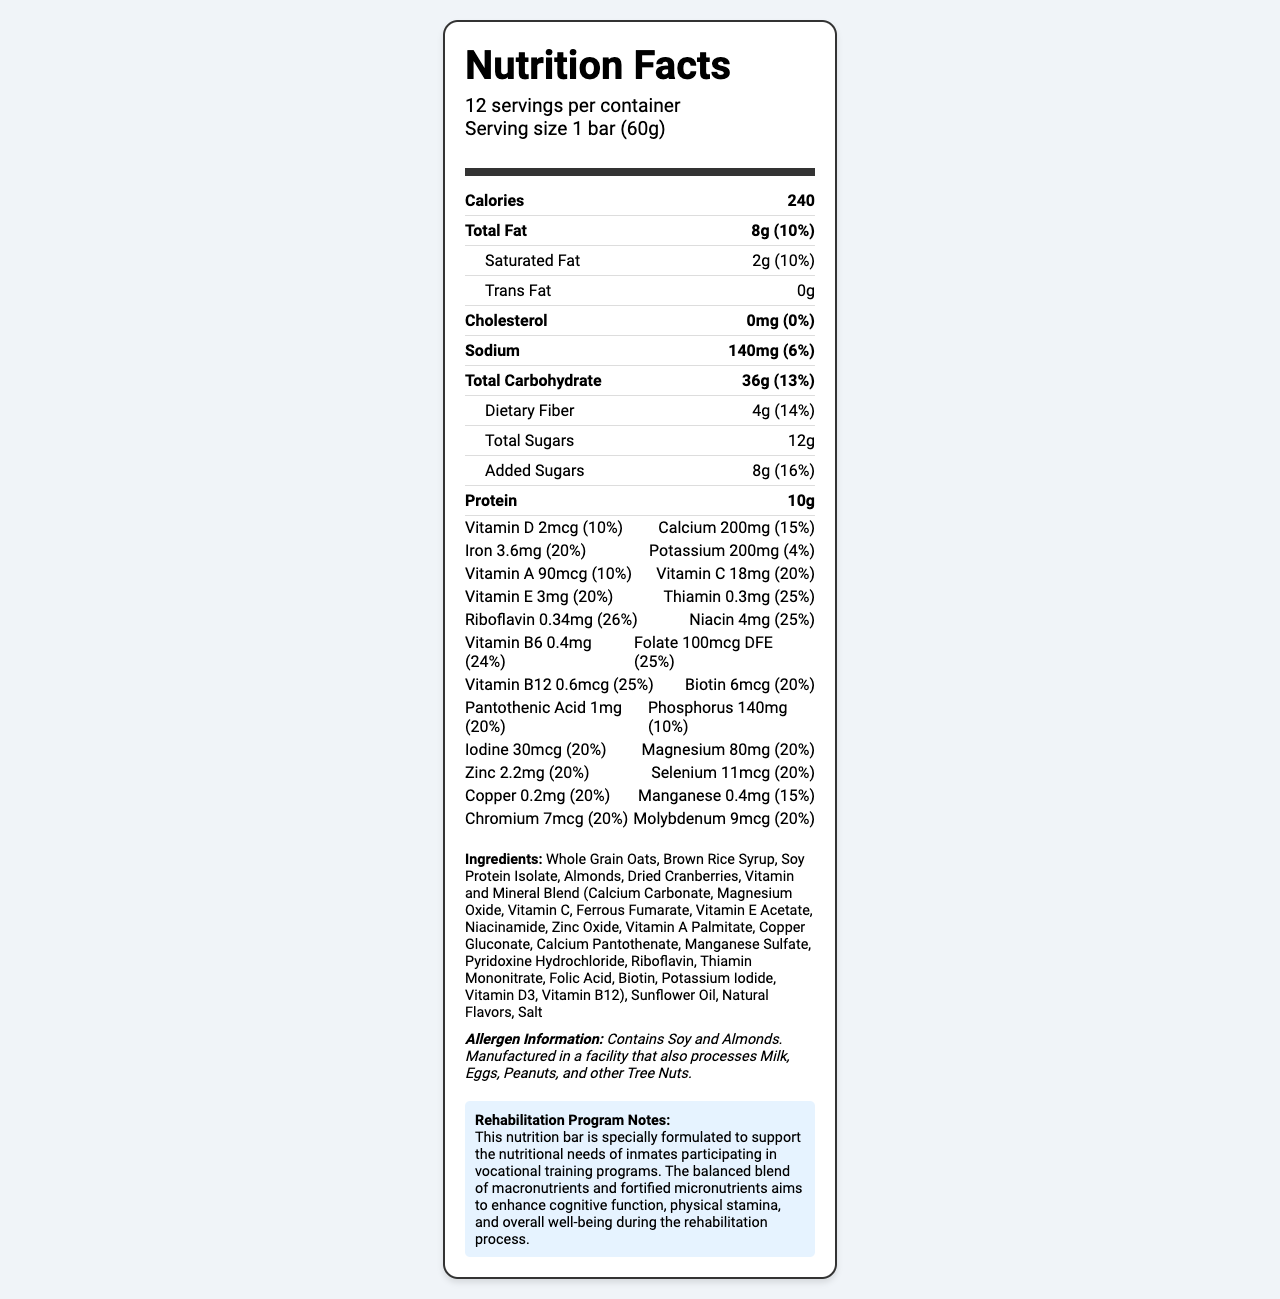what is the serving size? The serving size is clearly stated at the beginning of the document.
Answer: 1 bar (60g) how many servings are there per container? The document states that there are 12 servings per container.
Answer: 12 what is the total fat content per serving? The total fat content per serving is listed as 8g.
Answer: 8g how much protein does each serving contain? Each serving contains 10g of protein, as indicated in the nutrient row for protein.
Answer: 10g how much vitamin C is in each serving? The amount of vitamin C per serving is listed as 18mg in the vitamin-mineral row.
Answer: 18mg what percentage of the daily value is iron per serving? The daily value percentage for iron per serving is 20%, as shown in the document.
Answer: 20% which of the following vitamins has the highest daily value percentage? A. Vitamin D B. Vitamin C C. Thiamin D. Niacin Niacin has a daily value percentage of 25%, which is the highest among the listed options.
Answer: D. Niacin which ingredient is not included in the CorrectNutrition Vocational Boost Bar? A. Whole Grain Oats B. Soy Protein Isolate C. Chocolate D. Almonds Chocolate is not listed in the ingredient list, while the other options are.
Answer: C. Chocolate does the product contain any allergens? The allergen information at the bottom of the document states that the product contains soy and almonds.
Answer: Yes is this product fortified with micronutrients? The document mentions that the product contains a vitamin and mineral blend, indicating fortification with micronutrients.
Answer: Yes what is the primary purpose of the CorrectNutrition Vocational Boost Bar according to the rehabilitation program notes? The rehabilitation program notes clearly state this purpose.
Answer: To support the nutritional needs of inmates participating in vocational training programs how much calcium does each serving contain? The amount of calcium per serving is listed as 200mg in the vitamin-mineral row.
Answer: 200mg what is the cholesterol content per serving? The cholesterol content per serving is listed as 0mg in the nutrient row for cholesterol.
Answer: 0mg what are some of the main ingredients of the CorrectNutrition Vocational Boost Bar? These ingredients are the first few listed in the ingredients section.
Answer: Whole Grain Oats, Brown Rice Syrup, Soy Protein Isolate, Almonds, Dried Cranberries does this product contain any added sugars? The document lists 8g of added sugars, indicating that the product does contain added sugars.
Answer: Yes how much dietary fiber is in each serving? The amount of dietary fiber per serving is listed as 4g in the sub-nutrient row for carbohydrates.
Answer: 4g how many calories does one serving provide? The calorie content per serving is listed as 240 in the main nutrient row.
Answer: 240 summarize the main idea of this document. The document aims to offer comprehensive nutritional details relevant to the target audience while highlighting the benefits and purpose of the product in vocational training programs in correctional facilities.
Answer: The document provides detailed nutritional information for the CorrectNutrition Vocational Boost Bar, designed to support the nutritional needs of inmates in vocational training programs. It includes the serving size, calories, macronutrients, micronutrients, ingredients, allergen information, and notes on its purpose in rehabilitation programs. what is the carbohydrate content from sugars? The total sugars are listed as 12g, which contribute to the total carbohydrate content.
Answer: 12g does the product contain any sunflower oil? Sunflower oil is listed as one of the ingredients.
Answer: Yes how does the product aid rehabilitation programs according to the document? The rehabilitation notes specify that the product aims to support these aspects during rehabilitation.
Answer: By enhancing cognitive function, physical stamina, and overall well-being during the rehabilitation process what study supports the effectiveness of the nutritional blend in the CorrectNutrition Vocational Boost Bar? The document does not provide any references to studies or data supporting the effectiveness of the nutritional blend in the CorrectNutrition Vocational Boost Bar.
Answer: Not enough information 